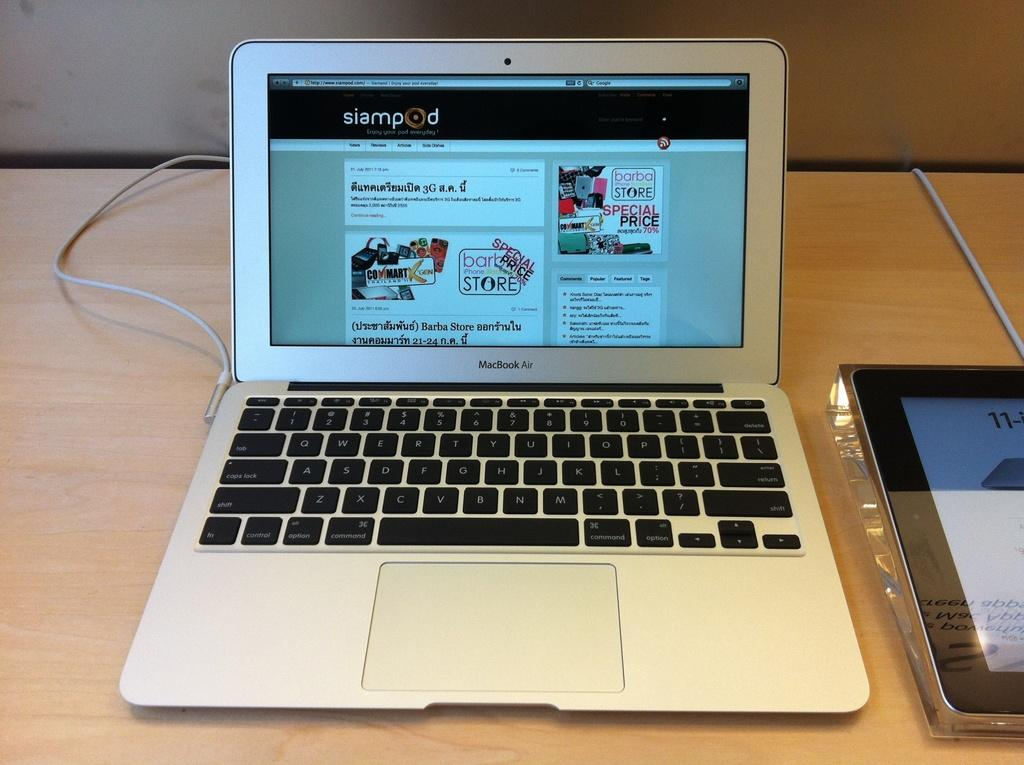What electronic device is present in the image? There is a laptop in the image. What is the laptop placed on? The laptop is placed on a table. What can be seen on the laptop screen? There is text and cartoon images visible on the laptop screen. Can you describe the device on the table? Unfortunately, the provided facts do not mention any details about the device on the table. How many cushions are present on the laptop in the image? There are no cushions present on the laptop in the image. What time is displayed on the laptop's clock in the image? There is no clock or hour mentioned in the image, so we cannot determine the time. 